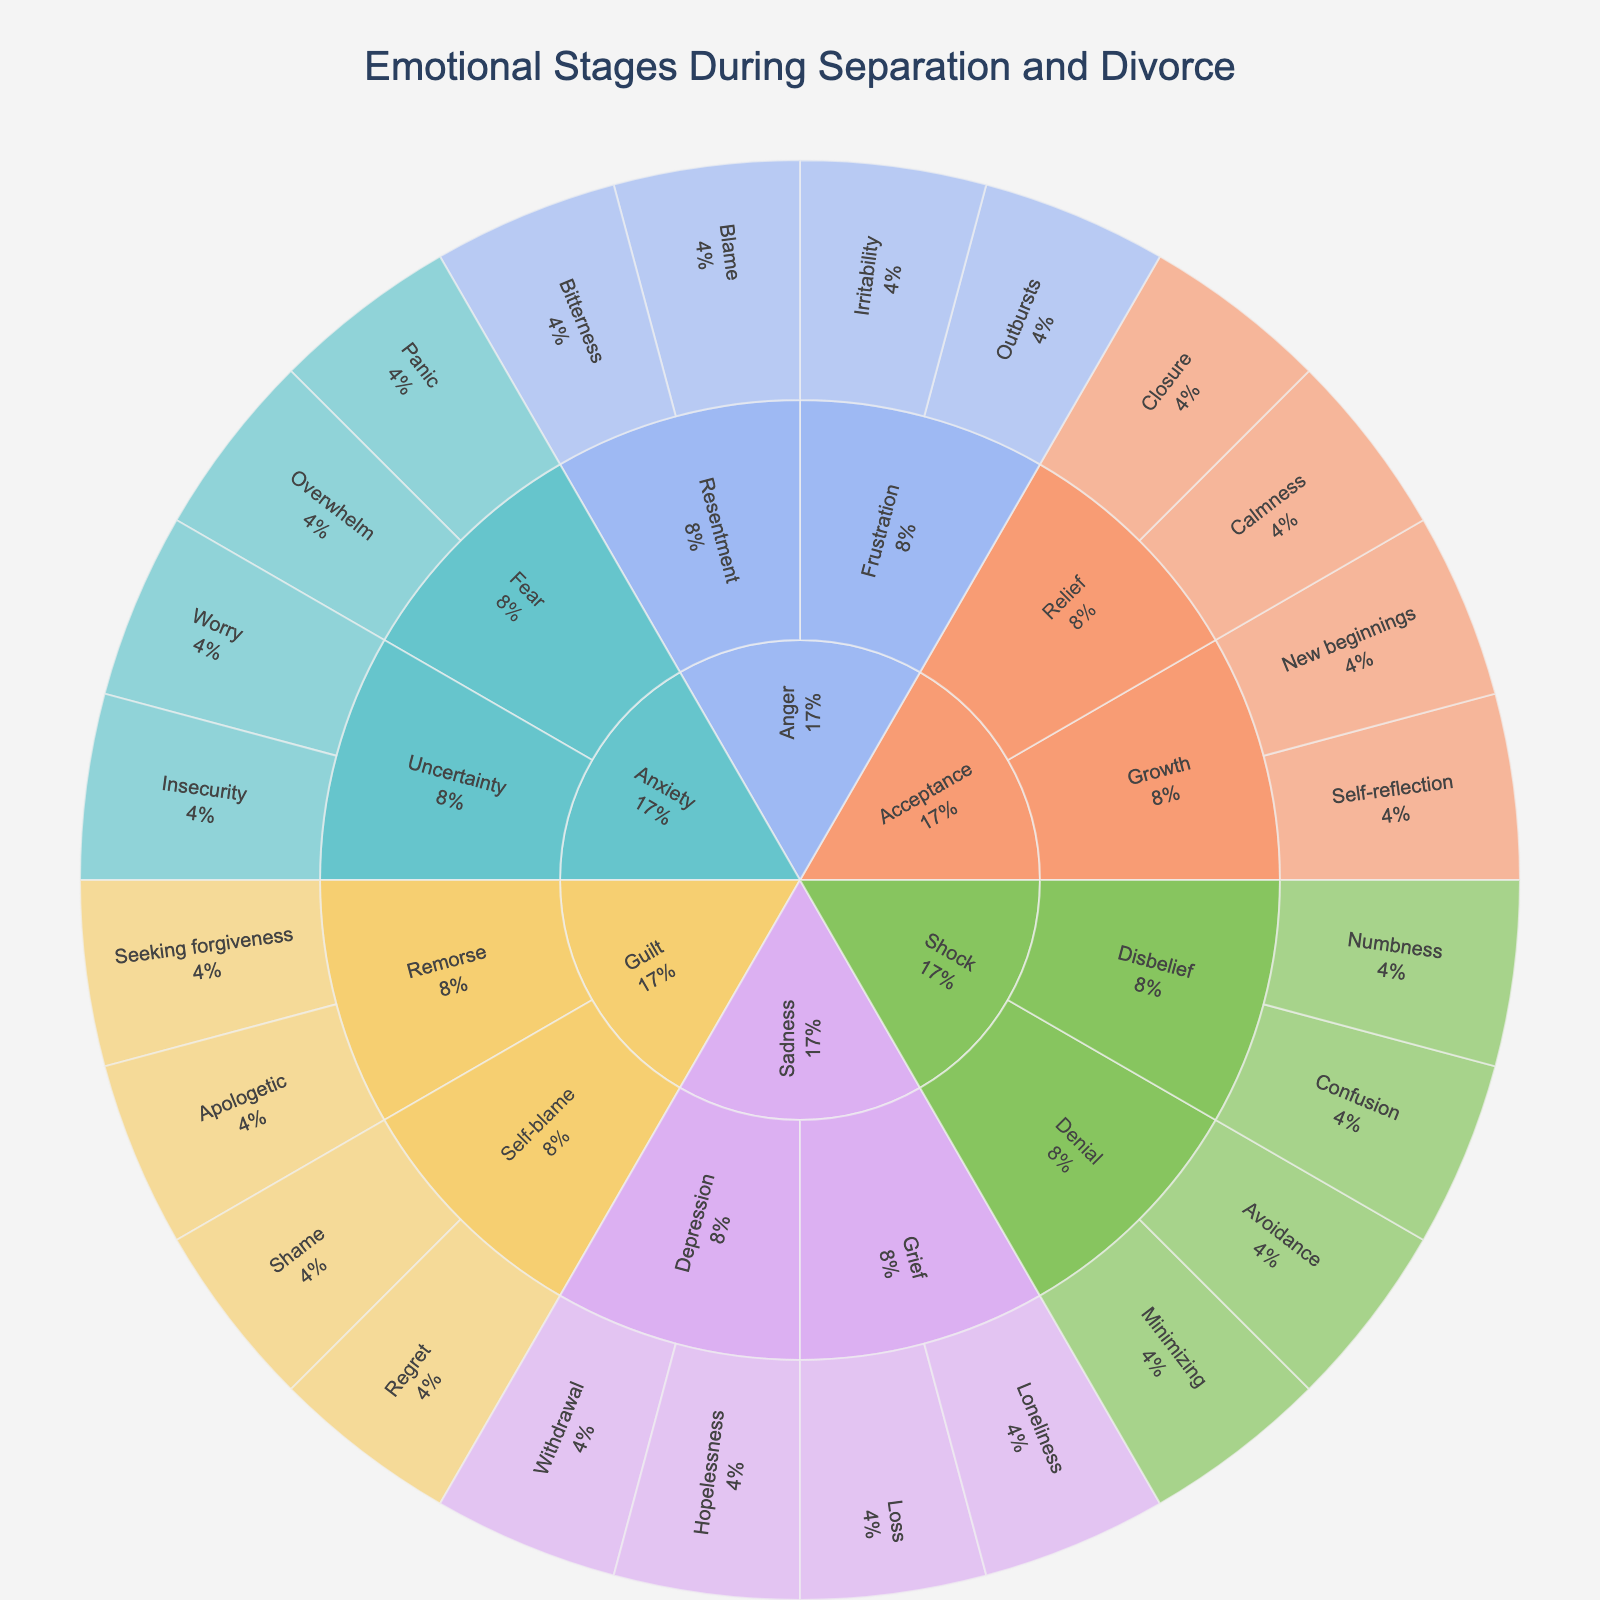What is the title of the figure? The title of the figure is typically placed at the top of a chart and is clearly labeled. In this instance, the title "Emotional Stages During Separation and Divorce" is displayed at the top center.
Answer: Emotional Stages During Separation and Divorce How many main emotional categories are present in the plot? Observe the central part of the Sunburst Plot where the main categories radiate out from the center. In this instance, there are six main categories visible in the plot.
Answer: Six What feelings are associated with the "Shock" category? Follow the branches from the "Shock" category outward to the subcategories and further to the individual feelings. The feelings are Numbness, Confusion, Avoidance, and Minimizing.
Answer: Numbness, Confusion, Avoidance, Minimizing Which category includes "Self-reflection" as a feeling? Identify the specific feeling "Self-reflection" and trace it back to its primary category. "Self-reflection" is under the "Acceptance" category, in the "Growth" subcategory.
Answer: Acceptance What is the percentage representation of "Anger" in comparison to "Sadness"? To answer this, you need to look at the proportion of the Sunburst sections corresponding to "Anger" and "Sadness". Determine the relative sizes of these sections by observing the visual slices they occupy. Given that the exact percentages are not specified, a visual estimation shows that both sections seem to have similar sizes.
Answer: Approximately equal Which feelings are encompassed by the subcategory "Grief" under "Sadness"? Follow the subcategory "Grief" under the "Sadness" category to reveal the associated feelings, which are Loss and Loneliness.
Answer: Loss, Loneliness Which emotional stage has "Blame" as a feeling under one of its subcategories? Trace the feeling "Blame" back to its subcategory and main category. "Blame" falls under the subcategory "Resentment" in the "Anger" category.
Answer: Anger How many subcategories are there under the "Acceptance" category? Count the number of distinct subcategories radiating from the "Acceptance" category. There are two subcategories visible: "Relief" and "Growth".
Answer: Two Which category has the subcategory "Fear"? Trace the subcategory "Fear" back to its main category. "Fear" is a subcategory under "Anxiety".
Answer: Anxiety Is "Seeking forgiveness" a feeling under "Guilt"? Yes, trace the feeling "Seeking forgiveness" back to its main category. It falls under the subcategory "Remorse" in the "Guilt" category.
Answer: Yes 